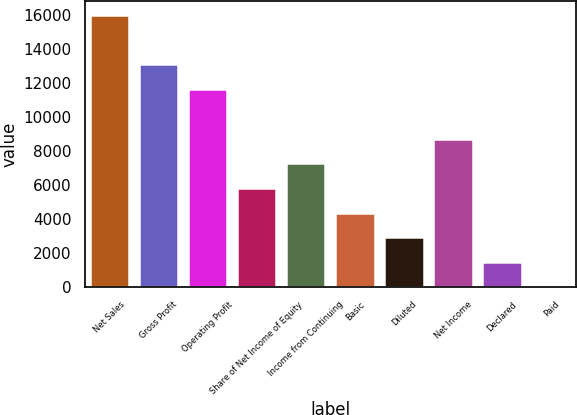Convert chart. <chart><loc_0><loc_0><loc_500><loc_500><bar_chart><fcel>Net Sales<fcel>Gross Profit<fcel>Operating Profit<fcel>Share of Net Income of Equity<fcel>Income from Continuing<fcel>Basic<fcel>Diluted<fcel>Net Income<fcel>Declared<fcel>Paid<nl><fcel>15972.6<fcel>13068.7<fcel>11616.8<fcel>5808.91<fcel>7260.87<fcel>4356.95<fcel>2904.99<fcel>8712.83<fcel>1453.03<fcel>1.07<nl></chart> 